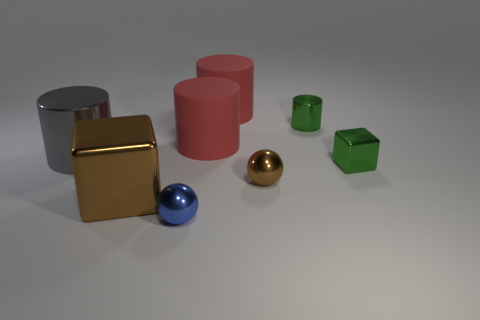The green object that is in front of the metallic thing behind the big cylinder that is to the left of the tiny blue thing is what shape?
Your answer should be compact. Cube. There is a metal thing that is behind the gray metallic object; is its shape the same as the large object that is in front of the green block?
Provide a short and direct response. No. What number of other objects are there of the same material as the tiny blue object?
Your response must be concise. 5. What is the shape of the big brown thing that is the same material as the gray object?
Your answer should be very brief. Cube. Is the size of the brown shiny cube the same as the gray metallic cylinder?
Provide a succinct answer. Yes. What size is the metallic object behind the shiny thing to the left of the big brown metallic cube?
Your response must be concise. Small. What shape is the thing that is the same color as the tiny shiny block?
Ensure brevity in your answer.  Cylinder. How many blocks are either tiny brown shiny things or red things?
Your response must be concise. 0. Does the brown cube have the same size as the brown shiny thing that is to the right of the big brown metal thing?
Your answer should be very brief. No. Is the number of small brown shiny objects in front of the small shiny cylinder greater than the number of balls?
Your answer should be very brief. No. 